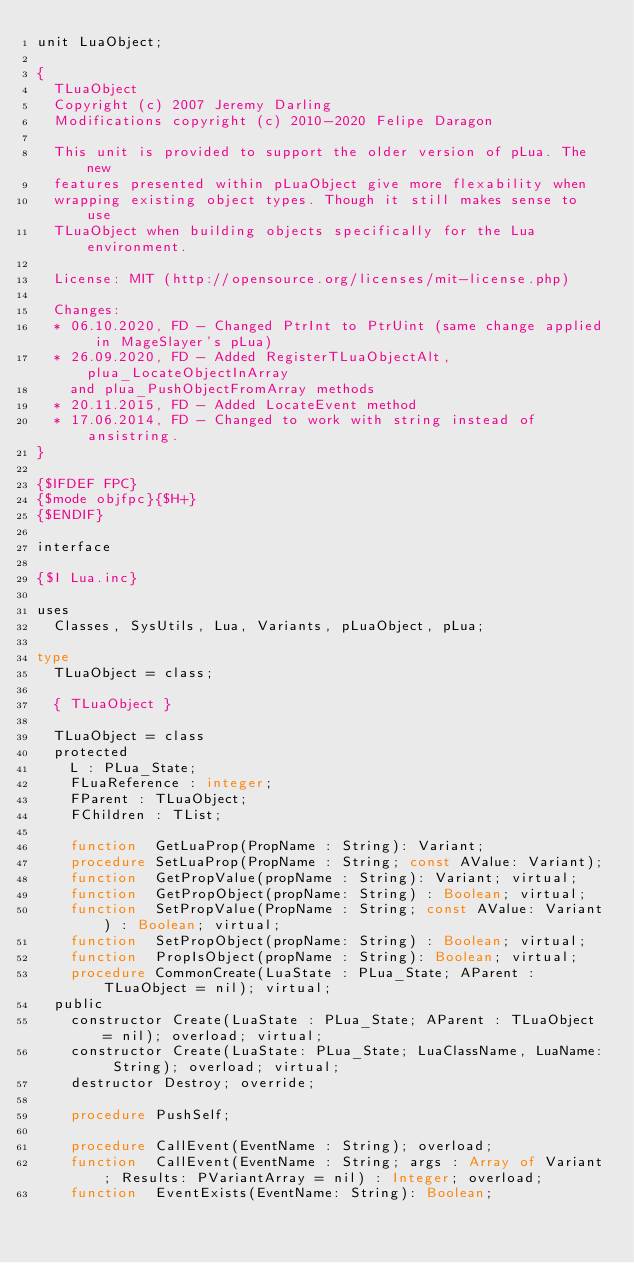<code> <loc_0><loc_0><loc_500><loc_500><_Pascal_>unit LuaObject;

{
  TLuaObject
  Copyright (c) 2007 Jeremy Darling
  Modifications copyright (c) 2010-2020 Felipe Daragon
  
  This unit is provided to support the older version of pLua. The new
  features presented within pLuaObject give more flexability when
  wrapping existing object types. Though it still makes sense to use
  TLuaObject when building objects specifically for the Lua environment.
  
  License: MIT (http://opensource.org/licenses/mit-license.php) 
  
  Changes:
  * 06.10.2020, FD - Changed PtrInt to PtrUint (same change applied in MageSlayer's pLua)
  * 26.09.2020, FD - Added RegisterTLuaObjectAlt, plua_LocateObjectInArray
    and plua_PushObjectFromArray methods
  * 20.11.2015, FD - Added LocateEvent method
  * 17.06.2014, FD - Changed to work with string instead of ansistring.
}

{$IFDEF FPC}
{$mode objfpc}{$H+}
{$ENDIF}

interface

{$I Lua.inc}

uses
  Classes, SysUtils, Lua, Variants, pLuaObject, pLua;

type
  TLuaObject = class;

  { TLuaObject }

  TLuaObject = class
  protected
    L : PLua_State;
    FLuaReference : integer;
    FParent : TLuaObject;
    FChildren : TList;
    
    function  GetLuaProp(PropName : String): Variant;
    procedure SetLuaProp(PropName : String; const AValue: Variant);
    function  GetPropValue(propName : String): Variant; virtual;
    function  GetPropObject(propName: String) : Boolean; virtual;
    function  SetPropValue(PropName : String; const AValue: Variant) : Boolean; virtual;
    function  SetPropObject(propName: String) : Boolean; virtual;
    function  PropIsObject(propName : String): Boolean; virtual;
    procedure CommonCreate(LuaState : PLua_State; AParent : TLuaObject = nil); virtual;
  public
    constructor Create(LuaState : PLua_State; AParent : TLuaObject = nil); overload; virtual;
    constructor Create(LuaState: PLua_State; LuaClassName, LuaName: String); overload; virtual;
    destructor Destroy; override;

    procedure PushSelf;

    procedure CallEvent(EventName : String); overload;
    function  CallEvent(EventName : String; args : Array of Variant; Results: PVariantArray = nil) : Integer; overload;
    function  EventExists(EventName: String): Boolean;</code> 